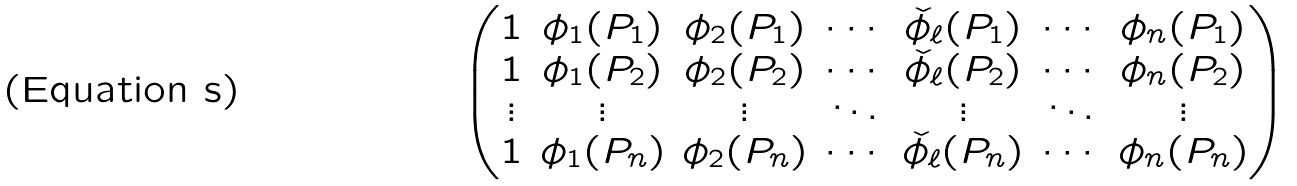<formula> <loc_0><loc_0><loc_500><loc_500>\begin{pmatrix} 1 & \phi _ { 1 } ( P _ { 1 } ) & \phi _ { 2 } ( P _ { 1 } ) & \cdots & \check { \phi _ { \ell } } ( P _ { 1 } ) & \cdots & \phi _ { n } ( P _ { 1 } ) \\ 1 & \phi _ { 1 } ( P _ { 2 } ) & \phi _ { 2 } ( P _ { 2 } ) & \cdots & \check { \phi _ { \ell } } ( P _ { 2 } ) & \cdots & \phi _ { n } ( P _ { 2 } ) \\ \vdots & \vdots & \vdots & \ddots & \vdots & \ddots & \vdots \\ 1 & \phi _ { 1 } ( P _ { n } ) & \phi _ { 2 } ( P _ { n } ) & \cdots & \check { \phi _ { \ell } } ( P _ { n } ) & \cdots & \phi _ { n } ( P _ { n } ) \end{pmatrix}</formula> 